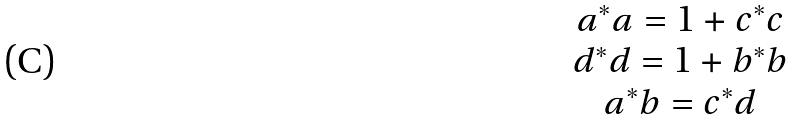Convert formula to latex. <formula><loc_0><loc_0><loc_500><loc_500>\begin{matrix} a ^ { * } a = 1 + c ^ { * } c \\ d ^ { * } d = 1 + b ^ { * } b \\ a ^ { * } b = c ^ { * } d \end{matrix}</formula> 